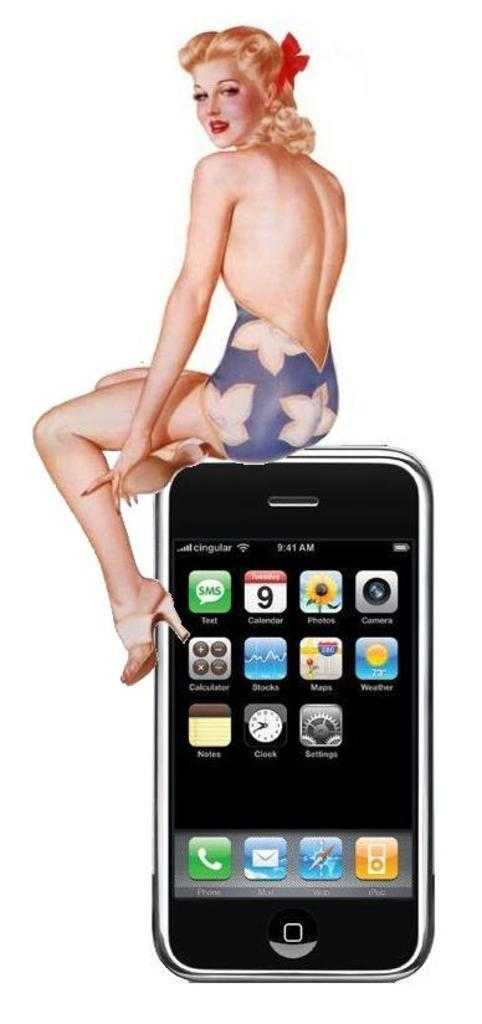What type of image is being described? The image is animated. What object can be seen in the image? There is a mobile phone in the image. Who is depicted in the image? There is an image of a woman sitting in the image. What expression does the woman have? The woman is smiling in the image. What type of cloth is being used to clean the waste in the image? There is no cloth or waste present in the image; it features an animated scene with a mobile phone and a smiling woman. 